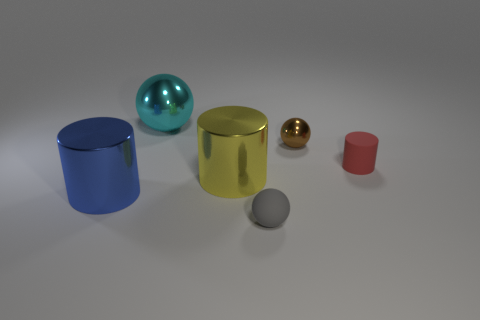Add 1 cyan metallic things. How many objects exist? 7 Subtract 0 yellow balls. How many objects are left? 6 Subtract all yellow things. Subtract all big metal spheres. How many objects are left? 4 Add 3 small gray matte things. How many small gray matte things are left? 4 Add 6 tiny brown cylinders. How many tiny brown cylinders exist? 6 